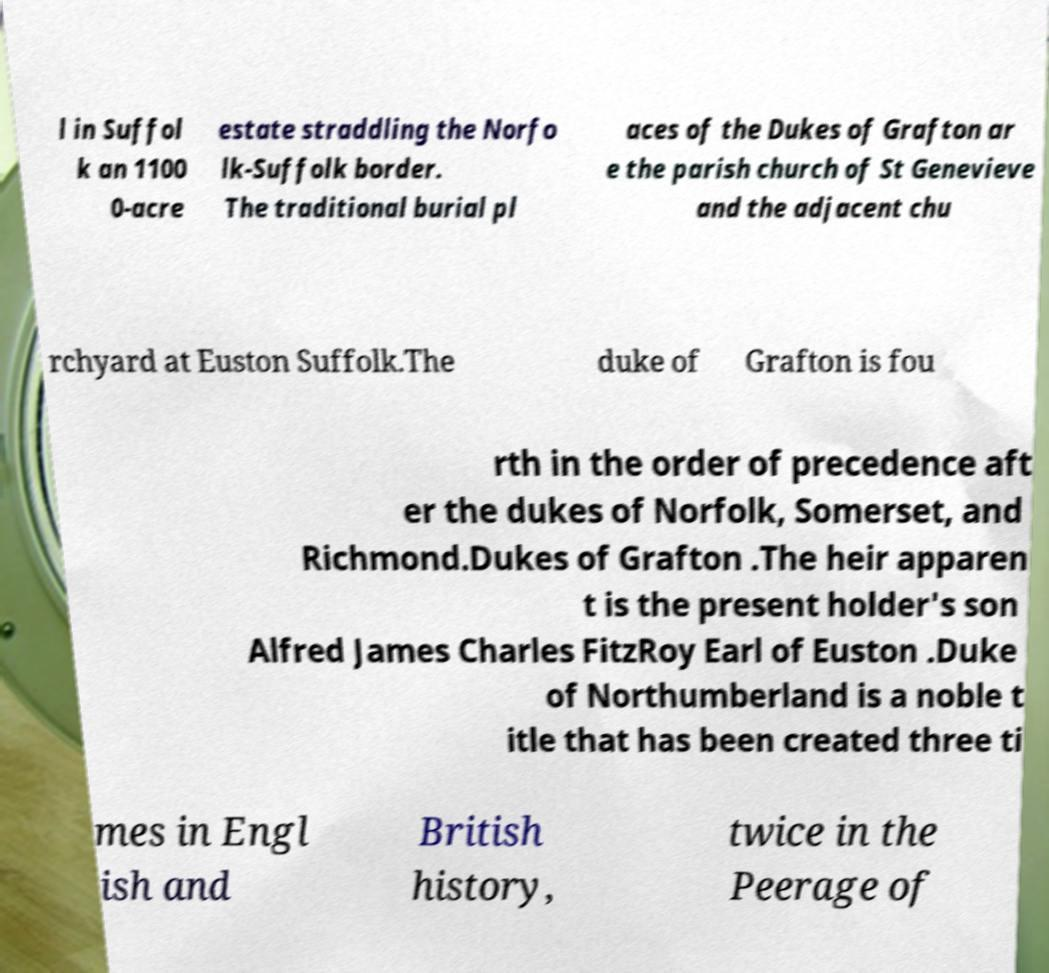Could you assist in decoding the text presented in this image and type it out clearly? l in Suffol k an 1100 0-acre estate straddling the Norfo lk-Suffolk border. The traditional burial pl aces of the Dukes of Grafton ar e the parish church of St Genevieve and the adjacent chu rchyard at Euston Suffolk.The duke of Grafton is fou rth in the order of precedence aft er the dukes of Norfolk, Somerset, and Richmond.Dukes of Grafton .The heir apparen t is the present holder's son Alfred James Charles FitzRoy Earl of Euston .Duke of Northumberland is a noble t itle that has been created three ti mes in Engl ish and British history, twice in the Peerage of 